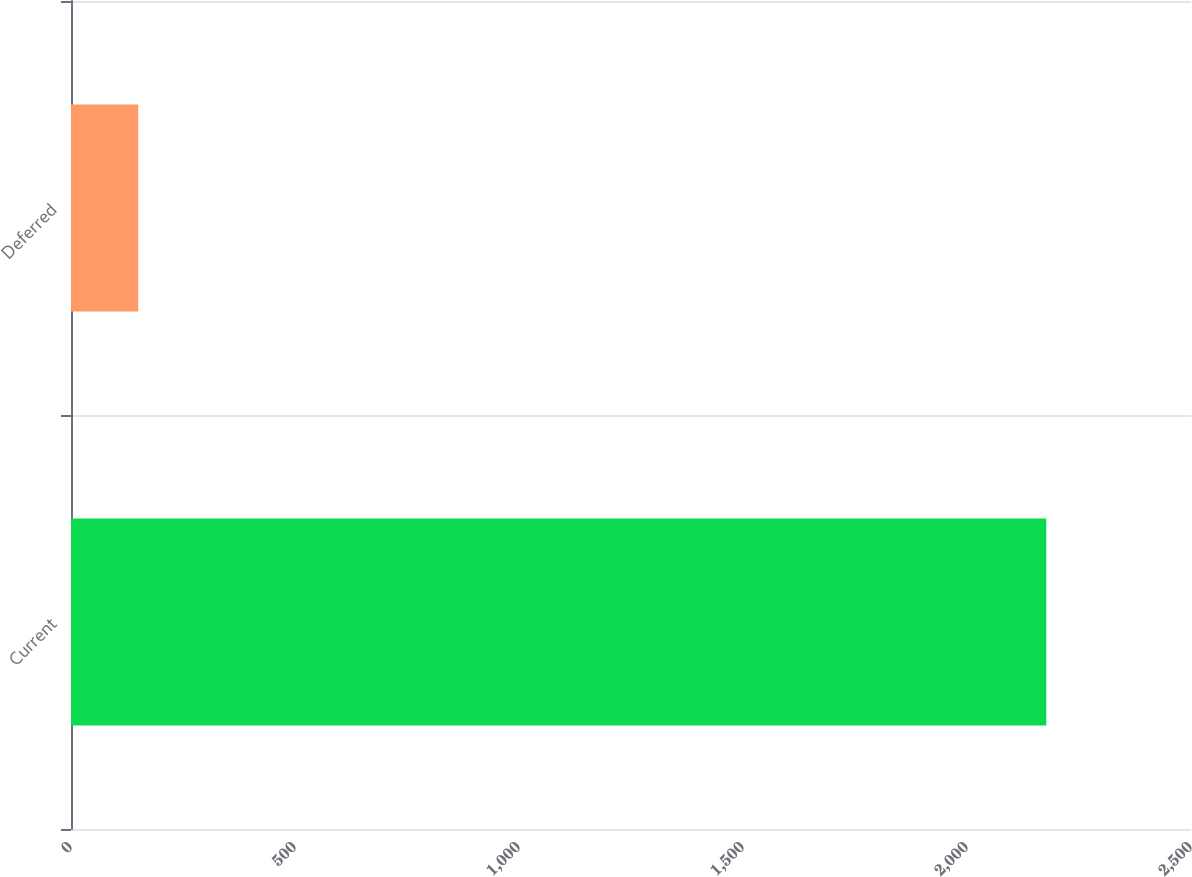Convert chart. <chart><loc_0><loc_0><loc_500><loc_500><bar_chart><fcel>Current<fcel>Deferred<nl><fcel>2177<fcel>150<nl></chart> 